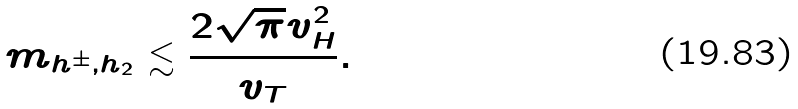Convert formula to latex. <formula><loc_0><loc_0><loc_500><loc_500>m _ { h ^ { \pm } , h _ { 2 } } \lesssim \frac { 2 \sqrt { \pi } v ^ { 2 } _ { H } } { v _ { T } } .</formula> 